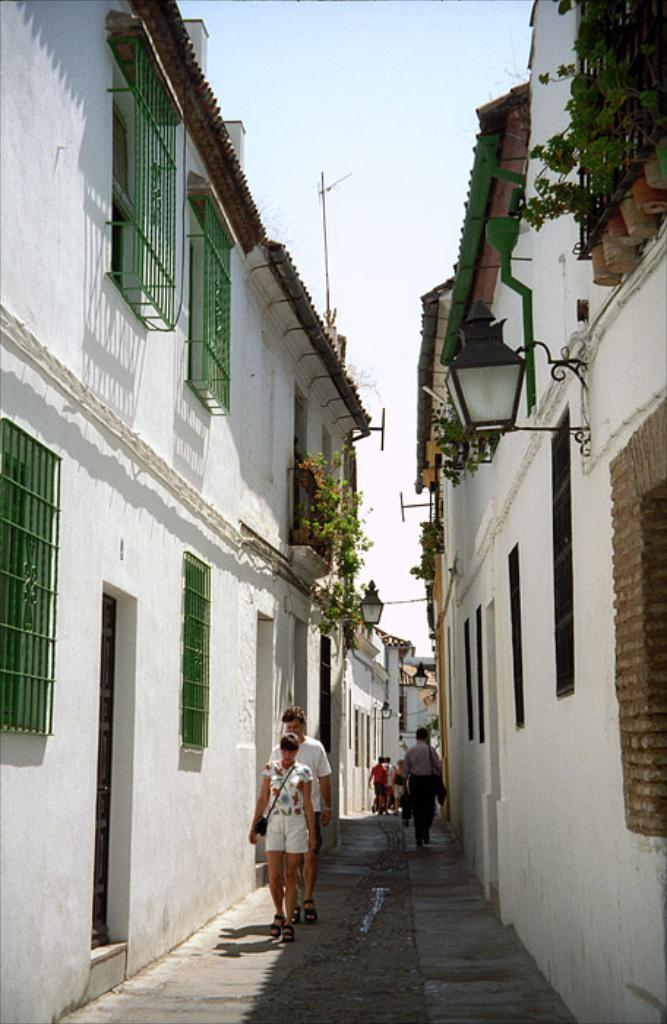How many persons are visible in the image? There are persons in the image, but the exact number is not specified. What type of structures can be seen in the image? There are buildings in the image. What architectural features are present in the image? There are windows in the image. What type of vegetation is visible in the image? There are plants in the image. What type of illumination is present in the image? There are lights in the image. What type of vertical structures are present in the image? There are poles in the image. What can be seen in the background of the image? The sky is visible in the background of the image. What type of bottle is being used to measure the degree of the plants in the image? There is no bottle or measurement of the plants present in the image. What is the opinion of the persons in the image regarding the lights? There is no indication of the persons' opinions regarding the lights in the image. 